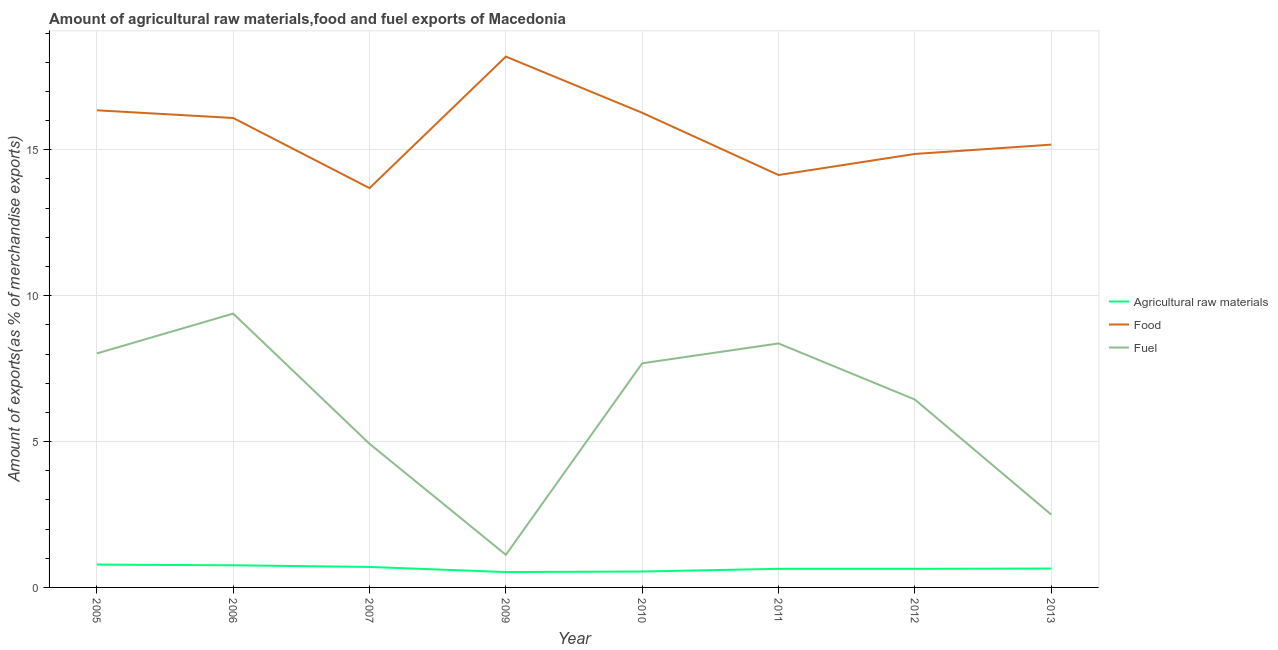Does the line corresponding to percentage of fuel exports intersect with the line corresponding to percentage of raw materials exports?
Keep it short and to the point. No. What is the percentage of food exports in 2013?
Give a very brief answer. 15.18. Across all years, what is the maximum percentage of food exports?
Your response must be concise. 18.19. Across all years, what is the minimum percentage of fuel exports?
Keep it short and to the point. 1.12. In which year was the percentage of food exports maximum?
Keep it short and to the point. 2009. What is the total percentage of fuel exports in the graph?
Offer a very short reply. 48.42. What is the difference between the percentage of raw materials exports in 2006 and that in 2007?
Give a very brief answer. 0.06. What is the difference between the percentage of raw materials exports in 2007 and the percentage of food exports in 2009?
Your response must be concise. -17.49. What is the average percentage of fuel exports per year?
Ensure brevity in your answer.  6.05. In the year 2012, what is the difference between the percentage of food exports and percentage of fuel exports?
Ensure brevity in your answer.  8.42. In how many years, is the percentage of raw materials exports greater than 15 %?
Keep it short and to the point. 0. What is the ratio of the percentage of food exports in 2009 to that in 2012?
Your answer should be compact. 1.22. What is the difference between the highest and the second highest percentage of food exports?
Your answer should be compact. 1.84. What is the difference between the highest and the lowest percentage of raw materials exports?
Your response must be concise. 0.25. Is the sum of the percentage of food exports in 2005 and 2011 greater than the maximum percentage of fuel exports across all years?
Your response must be concise. Yes. Is it the case that in every year, the sum of the percentage of raw materials exports and percentage of food exports is greater than the percentage of fuel exports?
Provide a short and direct response. Yes. How many lines are there?
Offer a very short reply. 3. How many years are there in the graph?
Provide a short and direct response. 8. Does the graph contain any zero values?
Ensure brevity in your answer.  No. Does the graph contain grids?
Give a very brief answer. Yes. How are the legend labels stacked?
Offer a terse response. Vertical. What is the title of the graph?
Provide a succinct answer. Amount of agricultural raw materials,food and fuel exports of Macedonia. What is the label or title of the Y-axis?
Your answer should be compact. Amount of exports(as % of merchandise exports). What is the Amount of exports(as % of merchandise exports) of Agricultural raw materials in 2005?
Keep it short and to the point. 0.78. What is the Amount of exports(as % of merchandise exports) in Food in 2005?
Provide a succinct answer. 16.35. What is the Amount of exports(as % of merchandise exports) of Fuel in 2005?
Provide a succinct answer. 8.02. What is the Amount of exports(as % of merchandise exports) in Agricultural raw materials in 2006?
Offer a terse response. 0.76. What is the Amount of exports(as % of merchandise exports) of Food in 2006?
Make the answer very short. 16.09. What is the Amount of exports(as % of merchandise exports) of Fuel in 2006?
Give a very brief answer. 9.38. What is the Amount of exports(as % of merchandise exports) of Agricultural raw materials in 2007?
Keep it short and to the point. 0.7. What is the Amount of exports(as % of merchandise exports) in Food in 2007?
Offer a terse response. 13.69. What is the Amount of exports(as % of merchandise exports) in Fuel in 2007?
Your response must be concise. 4.92. What is the Amount of exports(as % of merchandise exports) of Agricultural raw materials in 2009?
Offer a terse response. 0.53. What is the Amount of exports(as % of merchandise exports) of Food in 2009?
Ensure brevity in your answer.  18.19. What is the Amount of exports(as % of merchandise exports) in Fuel in 2009?
Your answer should be very brief. 1.12. What is the Amount of exports(as % of merchandise exports) of Agricultural raw materials in 2010?
Provide a succinct answer. 0.55. What is the Amount of exports(as % of merchandise exports) of Food in 2010?
Give a very brief answer. 16.27. What is the Amount of exports(as % of merchandise exports) in Fuel in 2010?
Offer a terse response. 7.68. What is the Amount of exports(as % of merchandise exports) in Agricultural raw materials in 2011?
Your response must be concise. 0.64. What is the Amount of exports(as % of merchandise exports) of Food in 2011?
Give a very brief answer. 14.13. What is the Amount of exports(as % of merchandise exports) in Fuel in 2011?
Keep it short and to the point. 8.36. What is the Amount of exports(as % of merchandise exports) in Agricultural raw materials in 2012?
Give a very brief answer. 0.64. What is the Amount of exports(as % of merchandise exports) of Food in 2012?
Offer a terse response. 14.86. What is the Amount of exports(as % of merchandise exports) of Fuel in 2012?
Your response must be concise. 6.44. What is the Amount of exports(as % of merchandise exports) in Agricultural raw materials in 2013?
Your answer should be compact. 0.65. What is the Amount of exports(as % of merchandise exports) of Food in 2013?
Give a very brief answer. 15.18. What is the Amount of exports(as % of merchandise exports) of Fuel in 2013?
Your answer should be very brief. 2.5. Across all years, what is the maximum Amount of exports(as % of merchandise exports) in Agricultural raw materials?
Keep it short and to the point. 0.78. Across all years, what is the maximum Amount of exports(as % of merchandise exports) of Food?
Your answer should be compact. 18.19. Across all years, what is the maximum Amount of exports(as % of merchandise exports) of Fuel?
Make the answer very short. 9.38. Across all years, what is the minimum Amount of exports(as % of merchandise exports) in Agricultural raw materials?
Your response must be concise. 0.53. Across all years, what is the minimum Amount of exports(as % of merchandise exports) of Food?
Give a very brief answer. 13.69. Across all years, what is the minimum Amount of exports(as % of merchandise exports) of Fuel?
Your answer should be very brief. 1.12. What is the total Amount of exports(as % of merchandise exports) in Agricultural raw materials in the graph?
Your response must be concise. 5.24. What is the total Amount of exports(as % of merchandise exports) of Food in the graph?
Give a very brief answer. 124.75. What is the total Amount of exports(as % of merchandise exports) in Fuel in the graph?
Provide a short and direct response. 48.42. What is the difference between the Amount of exports(as % of merchandise exports) of Agricultural raw materials in 2005 and that in 2006?
Your response must be concise. 0.02. What is the difference between the Amount of exports(as % of merchandise exports) of Food in 2005 and that in 2006?
Your answer should be very brief. 0.26. What is the difference between the Amount of exports(as % of merchandise exports) in Fuel in 2005 and that in 2006?
Offer a terse response. -1.37. What is the difference between the Amount of exports(as % of merchandise exports) of Agricultural raw materials in 2005 and that in 2007?
Offer a very short reply. 0.08. What is the difference between the Amount of exports(as % of merchandise exports) in Food in 2005 and that in 2007?
Your answer should be very brief. 2.67. What is the difference between the Amount of exports(as % of merchandise exports) of Fuel in 2005 and that in 2007?
Ensure brevity in your answer.  3.1. What is the difference between the Amount of exports(as % of merchandise exports) of Agricultural raw materials in 2005 and that in 2009?
Your answer should be very brief. 0.25. What is the difference between the Amount of exports(as % of merchandise exports) of Food in 2005 and that in 2009?
Make the answer very short. -1.84. What is the difference between the Amount of exports(as % of merchandise exports) in Fuel in 2005 and that in 2009?
Make the answer very short. 6.9. What is the difference between the Amount of exports(as % of merchandise exports) of Agricultural raw materials in 2005 and that in 2010?
Offer a very short reply. 0.24. What is the difference between the Amount of exports(as % of merchandise exports) in Food in 2005 and that in 2010?
Ensure brevity in your answer.  0.09. What is the difference between the Amount of exports(as % of merchandise exports) of Fuel in 2005 and that in 2010?
Give a very brief answer. 0.34. What is the difference between the Amount of exports(as % of merchandise exports) of Agricultural raw materials in 2005 and that in 2011?
Keep it short and to the point. 0.14. What is the difference between the Amount of exports(as % of merchandise exports) in Food in 2005 and that in 2011?
Your response must be concise. 2.22. What is the difference between the Amount of exports(as % of merchandise exports) in Fuel in 2005 and that in 2011?
Offer a very short reply. -0.34. What is the difference between the Amount of exports(as % of merchandise exports) of Agricultural raw materials in 2005 and that in 2012?
Give a very brief answer. 0.14. What is the difference between the Amount of exports(as % of merchandise exports) in Food in 2005 and that in 2012?
Offer a very short reply. 1.5. What is the difference between the Amount of exports(as % of merchandise exports) of Fuel in 2005 and that in 2012?
Give a very brief answer. 1.58. What is the difference between the Amount of exports(as % of merchandise exports) of Agricultural raw materials in 2005 and that in 2013?
Your answer should be very brief. 0.13. What is the difference between the Amount of exports(as % of merchandise exports) of Food in 2005 and that in 2013?
Give a very brief answer. 1.18. What is the difference between the Amount of exports(as % of merchandise exports) of Fuel in 2005 and that in 2013?
Your answer should be compact. 5.52. What is the difference between the Amount of exports(as % of merchandise exports) in Agricultural raw materials in 2006 and that in 2007?
Provide a succinct answer. 0.06. What is the difference between the Amount of exports(as % of merchandise exports) in Food in 2006 and that in 2007?
Ensure brevity in your answer.  2.4. What is the difference between the Amount of exports(as % of merchandise exports) of Fuel in 2006 and that in 2007?
Provide a succinct answer. 4.46. What is the difference between the Amount of exports(as % of merchandise exports) in Agricultural raw materials in 2006 and that in 2009?
Keep it short and to the point. 0.23. What is the difference between the Amount of exports(as % of merchandise exports) in Food in 2006 and that in 2009?
Your response must be concise. -2.1. What is the difference between the Amount of exports(as % of merchandise exports) in Fuel in 2006 and that in 2009?
Make the answer very short. 8.27. What is the difference between the Amount of exports(as % of merchandise exports) of Agricultural raw materials in 2006 and that in 2010?
Your answer should be very brief. 0.21. What is the difference between the Amount of exports(as % of merchandise exports) in Food in 2006 and that in 2010?
Your response must be concise. -0.18. What is the difference between the Amount of exports(as % of merchandise exports) of Fuel in 2006 and that in 2010?
Ensure brevity in your answer.  1.7. What is the difference between the Amount of exports(as % of merchandise exports) of Agricultural raw materials in 2006 and that in 2011?
Make the answer very short. 0.12. What is the difference between the Amount of exports(as % of merchandise exports) in Food in 2006 and that in 2011?
Your response must be concise. 1.96. What is the difference between the Amount of exports(as % of merchandise exports) in Fuel in 2006 and that in 2011?
Your answer should be compact. 1.02. What is the difference between the Amount of exports(as % of merchandise exports) of Agricultural raw materials in 2006 and that in 2012?
Offer a very short reply. 0.12. What is the difference between the Amount of exports(as % of merchandise exports) in Food in 2006 and that in 2012?
Offer a very short reply. 1.23. What is the difference between the Amount of exports(as % of merchandise exports) of Fuel in 2006 and that in 2012?
Offer a very short reply. 2.95. What is the difference between the Amount of exports(as % of merchandise exports) of Agricultural raw materials in 2006 and that in 2013?
Ensure brevity in your answer.  0.11. What is the difference between the Amount of exports(as % of merchandise exports) of Food in 2006 and that in 2013?
Ensure brevity in your answer.  0.91. What is the difference between the Amount of exports(as % of merchandise exports) of Fuel in 2006 and that in 2013?
Ensure brevity in your answer.  6.89. What is the difference between the Amount of exports(as % of merchandise exports) in Agricultural raw materials in 2007 and that in 2009?
Ensure brevity in your answer.  0.17. What is the difference between the Amount of exports(as % of merchandise exports) of Food in 2007 and that in 2009?
Keep it short and to the point. -4.51. What is the difference between the Amount of exports(as % of merchandise exports) in Fuel in 2007 and that in 2009?
Provide a succinct answer. 3.8. What is the difference between the Amount of exports(as % of merchandise exports) in Agricultural raw materials in 2007 and that in 2010?
Offer a terse response. 0.16. What is the difference between the Amount of exports(as % of merchandise exports) of Food in 2007 and that in 2010?
Your response must be concise. -2.58. What is the difference between the Amount of exports(as % of merchandise exports) of Fuel in 2007 and that in 2010?
Offer a very short reply. -2.76. What is the difference between the Amount of exports(as % of merchandise exports) in Agricultural raw materials in 2007 and that in 2011?
Make the answer very short. 0.06. What is the difference between the Amount of exports(as % of merchandise exports) in Food in 2007 and that in 2011?
Offer a very short reply. -0.45. What is the difference between the Amount of exports(as % of merchandise exports) of Fuel in 2007 and that in 2011?
Your answer should be compact. -3.44. What is the difference between the Amount of exports(as % of merchandise exports) in Agricultural raw materials in 2007 and that in 2012?
Ensure brevity in your answer.  0.06. What is the difference between the Amount of exports(as % of merchandise exports) in Food in 2007 and that in 2012?
Your answer should be very brief. -1.17. What is the difference between the Amount of exports(as % of merchandise exports) in Fuel in 2007 and that in 2012?
Make the answer very short. -1.52. What is the difference between the Amount of exports(as % of merchandise exports) in Agricultural raw materials in 2007 and that in 2013?
Ensure brevity in your answer.  0.05. What is the difference between the Amount of exports(as % of merchandise exports) in Food in 2007 and that in 2013?
Your answer should be compact. -1.49. What is the difference between the Amount of exports(as % of merchandise exports) in Fuel in 2007 and that in 2013?
Keep it short and to the point. 2.43. What is the difference between the Amount of exports(as % of merchandise exports) in Agricultural raw materials in 2009 and that in 2010?
Offer a terse response. -0.02. What is the difference between the Amount of exports(as % of merchandise exports) of Food in 2009 and that in 2010?
Provide a succinct answer. 1.93. What is the difference between the Amount of exports(as % of merchandise exports) in Fuel in 2009 and that in 2010?
Offer a terse response. -6.56. What is the difference between the Amount of exports(as % of merchandise exports) in Agricultural raw materials in 2009 and that in 2011?
Provide a succinct answer. -0.11. What is the difference between the Amount of exports(as % of merchandise exports) of Food in 2009 and that in 2011?
Offer a terse response. 4.06. What is the difference between the Amount of exports(as % of merchandise exports) in Fuel in 2009 and that in 2011?
Make the answer very short. -7.24. What is the difference between the Amount of exports(as % of merchandise exports) of Agricultural raw materials in 2009 and that in 2012?
Keep it short and to the point. -0.11. What is the difference between the Amount of exports(as % of merchandise exports) of Food in 2009 and that in 2012?
Make the answer very short. 3.34. What is the difference between the Amount of exports(as % of merchandise exports) in Fuel in 2009 and that in 2012?
Make the answer very short. -5.32. What is the difference between the Amount of exports(as % of merchandise exports) in Agricultural raw materials in 2009 and that in 2013?
Offer a terse response. -0.12. What is the difference between the Amount of exports(as % of merchandise exports) of Food in 2009 and that in 2013?
Your answer should be very brief. 3.02. What is the difference between the Amount of exports(as % of merchandise exports) in Fuel in 2009 and that in 2013?
Your answer should be very brief. -1.38. What is the difference between the Amount of exports(as % of merchandise exports) in Agricultural raw materials in 2010 and that in 2011?
Ensure brevity in your answer.  -0.09. What is the difference between the Amount of exports(as % of merchandise exports) in Food in 2010 and that in 2011?
Offer a terse response. 2.13. What is the difference between the Amount of exports(as % of merchandise exports) in Fuel in 2010 and that in 2011?
Your response must be concise. -0.68. What is the difference between the Amount of exports(as % of merchandise exports) of Agricultural raw materials in 2010 and that in 2012?
Your answer should be very brief. -0.09. What is the difference between the Amount of exports(as % of merchandise exports) in Food in 2010 and that in 2012?
Offer a very short reply. 1.41. What is the difference between the Amount of exports(as % of merchandise exports) of Fuel in 2010 and that in 2012?
Keep it short and to the point. 1.24. What is the difference between the Amount of exports(as % of merchandise exports) in Agricultural raw materials in 2010 and that in 2013?
Keep it short and to the point. -0.1. What is the difference between the Amount of exports(as % of merchandise exports) in Food in 2010 and that in 2013?
Your answer should be very brief. 1.09. What is the difference between the Amount of exports(as % of merchandise exports) in Fuel in 2010 and that in 2013?
Offer a very short reply. 5.19. What is the difference between the Amount of exports(as % of merchandise exports) in Food in 2011 and that in 2012?
Your answer should be compact. -0.72. What is the difference between the Amount of exports(as % of merchandise exports) in Fuel in 2011 and that in 2012?
Your response must be concise. 1.92. What is the difference between the Amount of exports(as % of merchandise exports) of Agricultural raw materials in 2011 and that in 2013?
Your answer should be very brief. -0.01. What is the difference between the Amount of exports(as % of merchandise exports) of Food in 2011 and that in 2013?
Ensure brevity in your answer.  -1.04. What is the difference between the Amount of exports(as % of merchandise exports) of Fuel in 2011 and that in 2013?
Give a very brief answer. 5.86. What is the difference between the Amount of exports(as % of merchandise exports) of Agricultural raw materials in 2012 and that in 2013?
Offer a terse response. -0.01. What is the difference between the Amount of exports(as % of merchandise exports) in Food in 2012 and that in 2013?
Offer a terse response. -0.32. What is the difference between the Amount of exports(as % of merchandise exports) in Fuel in 2012 and that in 2013?
Offer a very short reply. 3.94. What is the difference between the Amount of exports(as % of merchandise exports) of Agricultural raw materials in 2005 and the Amount of exports(as % of merchandise exports) of Food in 2006?
Ensure brevity in your answer.  -15.31. What is the difference between the Amount of exports(as % of merchandise exports) of Agricultural raw materials in 2005 and the Amount of exports(as % of merchandise exports) of Fuel in 2006?
Make the answer very short. -8.6. What is the difference between the Amount of exports(as % of merchandise exports) in Food in 2005 and the Amount of exports(as % of merchandise exports) in Fuel in 2006?
Your answer should be compact. 6.97. What is the difference between the Amount of exports(as % of merchandise exports) of Agricultural raw materials in 2005 and the Amount of exports(as % of merchandise exports) of Food in 2007?
Provide a short and direct response. -12.9. What is the difference between the Amount of exports(as % of merchandise exports) of Agricultural raw materials in 2005 and the Amount of exports(as % of merchandise exports) of Fuel in 2007?
Keep it short and to the point. -4.14. What is the difference between the Amount of exports(as % of merchandise exports) in Food in 2005 and the Amount of exports(as % of merchandise exports) in Fuel in 2007?
Your answer should be very brief. 11.43. What is the difference between the Amount of exports(as % of merchandise exports) in Agricultural raw materials in 2005 and the Amount of exports(as % of merchandise exports) in Food in 2009?
Keep it short and to the point. -17.41. What is the difference between the Amount of exports(as % of merchandise exports) of Agricultural raw materials in 2005 and the Amount of exports(as % of merchandise exports) of Fuel in 2009?
Your answer should be compact. -0.34. What is the difference between the Amount of exports(as % of merchandise exports) in Food in 2005 and the Amount of exports(as % of merchandise exports) in Fuel in 2009?
Ensure brevity in your answer.  15.23. What is the difference between the Amount of exports(as % of merchandise exports) of Agricultural raw materials in 2005 and the Amount of exports(as % of merchandise exports) of Food in 2010?
Provide a short and direct response. -15.48. What is the difference between the Amount of exports(as % of merchandise exports) in Agricultural raw materials in 2005 and the Amount of exports(as % of merchandise exports) in Fuel in 2010?
Your response must be concise. -6.9. What is the difference between the Amount of exports(as % of merchandise exports) in Food in 2005 and the Amount of exports(as % of merchandise exports) in Fuel in 2010?
Your response must be concise. 8.67. What is the difference between the Amount of exports(as % of merchandise exports) of Agricultural raw materials in 2005 and the Amount of exports(as % of merchandise exports) of Food in 2011?
Provide a succinct answer. -13.35. What is the difference between the Amount of exports(as % of merchandise exports) in Agricultural raw materials in 2005 and the Amount of exports(as % of merchandise exports) in Fuel in 2011?
Make the answer very short. -7.58. What is the difference between the Amount of exports(as % of merchandise exports) of Food in 2005 and the Amount of exports(as % of merchandise exports) of Fuel in 2011?
Offer a terse response. 7.99. What is the difference between the Amount of exports(as % of merchandise exports) in Agricultural raw materials in 2005 and the Amount of exports(as % of merchandise exports) in Food in 2012?
Provide a short and direct response. -14.07. What is the difference between the Amount of exports(as % of merchandise exports) in Agricultural raw materials in 2005 and the Amount of exports(as % of merchandise exports) in Fuel in 2012?
Offer a very short reply. -5.66. What is the difference between the Amount of exports(as % of merchandise exports) of Food in 2005 and the Amount of exports(as % of merchandise exports) of Fuel in 2012?
Give a very brief answer. 9.91. What is the difference between the Amount of exports(as % of merchandise exports) of Agricultural raw materials in 2005 and the Amount of exports(as % of merchandise exports) of Food in 2013?
Offer a very short reply. -14.39. What is the difference between the Amount of exports(as % of merchandise exports) of Agricultural raw materials in 2005 and the Amount of exports(as % of merchandise exports) of Fuel in 2013?
Your response must be concise. -1.72. What is the difference between the Amount of exports(as % of merchandise exports) in Food in 2005 and the Amount of exports(as % of merchandise exports) in Fuel in 2013?
Your answer should be compact. 13.86. What is the difference between the Amount of exports(as % of merchandise exports) in Agricultural raw materials in 2006 and the Amount of exports(as % of merchandise exports) in Food in 2007?
Offer a terse response. -12.93. What is the difference between the Amount of exports(as % of merchandise exports) in Agricultural raw materials in 2006 and the Amount of exports(as % of merchandise exports) in Fuel in 2007?
Offer a terse response. -4.16. What is the difference between the Amount of exports(as % of merchandise exports) of Food in 2006 and the Amount of exports(as % of merchandise exports) of Fuel in 2007?
Keep it short and to the point. 11.17. What is the difference between the Amount of exports(as % of merchandise exports) of Agricultural raw materials in 2006 and the Amount of exports(as % of merchandise exports) of Food in 2009?
Give a very brief answer. -17.43. What is the difference between the Amount of exports(as % of merchandise exports) of Agricultural raw materials in 2006 and the Amount of exports(as % of merchandise exports) of Fuel in 2009?
Offer a terse response. -0.36. What is the difference between the Amount of exports(as % of merchandise exports) of Food in 2006 and the Amount of exports(as % of merchandise exports) of Fuel in 2009?
Make the answer very short. 14.97. What is the difference between the Amount of exports(as % of merchandise exports) of Agricultural raw materials in 2006 and the Amount of exports(as % of merchandise exports) of Food in 2010?
Provide a short and direct response. -15.51. What is the difference between the Amount of exports(as % of merchandise exports) in Agricultural raw materials in 2006 and the Amount of exports(as % of merchandise exports) in Fuel in 2010?
Your answer should be very brief. -6.92. What is the difference between the Amount of exports(as % of merchandise exports) in Food in 2006 and the Amount of exports(as % of merchandise exports) in Fuel in 2010?
Your answer should be compact. 8.41. What is the difference between the Amount of exports(as % of merchandise exports) of Agricultural raw materials in 2006 and the Amount of exports(as % of merchandise exports) of Food in 2011?
Provide a short and direct response. -13.37. What is the difference between the Amount of exports(as % of merchandise exports) of Agricultural raw materials in 2006 and the Amount of exports(as % of merchandise exports) of Fuel in 2011?
Offer a terse response. -7.6. What is the difference between the Amount of exports(as % of merchandise exports) of Food in 2006 and the Amount of exports(as % of merchandise exports) of Fuel in 2011?
Provide a short and direct response. 7.73. What is the difference between the Amount of exports(as % of merchandise exports) in Agricultural raw materials in 2006 and the Amount of exports(as % of merchandise exports) in Food in 2012?
Your answer should be compact. -14.1. What is the difference between the Amount of exports(as % of merchandise exports) of Agricultural raw materials in 2006 and the Amount of exports(as % of merchandise exports) of Fuel in 2012?
Your answer should be very brief. -5.68. What is the difference between the Amount of exports(as % of merchandise exports) in Food in 2006 and the Amount of exports(as % of merchandise exports) in Fuel in 2012?
Make the answer very short. 9.65. What is the difference between the Amount of exports(as % of merchandise exports) in Agricultural raw materials in 2006 and the Amount of exports(as % of merchandise exports) in Food in 2013?
Your response must be concise. -14.42. What is the difference between the Amount of exports(as % of merchandise exports) in Agricultural raw materials in 2006 and the Amount of exports(as % of merchandise exports) in Fuel in 2013?
Your answer should be compact. -1.74. What is the difference between the Amount of exports(as % of merchandise exports) of Food in 2006 and the Amount of exports(as % of merchandise exports) of Fuel in 2013?
Provide a short and direct response. 13.59. What is the difference between the Amount of exports(as % of merchandise exports) of Agricultural raw materials in 2007 and the Amount of exports(as % of merchandise exports) of Food in 2009?
Ensure brevity in your answer.  -17.49. What is the difference between the Amount of exports(as % of merchandise exports) in Agricultural raw materials in 2007 and the Amount of exports(as % of merchandise exports) in Fuel in 2009?
Keep it short and to the point. -0.42. What is the difference between the Amount of exports(as % of merchandise exports) of Food in 2007 and the Amount of exports(as % of merchandise exports) of Fuel in 2009?
Provide a short and direct response. 12.57. What is the difference between the Amount of exports(as % of merchandise exports) of Agricultural raw materials in 2007 and the Amount of exports(as % of merchandise exports) of Food in 2010?
Your answer should be compact. -15.56. What is the difference between the Amount of exports(as % of merchandise exports) of Agricultural raw materials in 2007 and the Amount of exports(as % of merchandise exports) of Fuel in 2010?
Provide a short and direct response. -6.98. What is the difference between the Amount of exports(as % of merchandise exports) in Food in 2007 and the Amount of exports(as % of merchandise exports) in Fuel in 2010?
Keep it short and to the point. 6. What is the difference between the Amount of exports(as % of merchandise exports) of Agricultural raw materials in 2007 and the Amount of exports(as % of merchandise exports) of Food in 2011?
Provide a short and direct response. -13.43. What is the difference between the Amount of exports(as % of merchandise exports) in Agricultural raw materials in 2007 and the Amount of exports(as % of merchandise exports) in Fuel in 2011?
Keep it short and to the point. -7.66. What is the difference between the Amount of exports(as % of merchandise exports) of Food in 2007 and the Amount of exports(as % of merchandise exports) of Fuel in 2011?
Offer a very short reply. 5.32. What is the difference between the Amount of exports(as % of merchandise exports) in Agricultural raw materials in 2007 and the Amount of exports(as % of merchandise exports) in Food in 2012?
Provide a short and direct response. -14.15. What is the difference between the Amount of exports(as % of merchandise exports) in Agricultural raw materials in 2007 and the Amount of exports(as % of merchandise exports) in Fuel in 2012?
Ensure brevity in your answer.  -5.74. What is the difference between the Amount of exports(as % of merchandise exports) of Food in 2007 and the Amount of exports(as % of merchandise exports) of Fuel in 2012?
Offer a very short reply. 7.25. What is the difference between the Amount of exports(as % of merchandise exports) of Agricultural raw materials in 2007 and the Amount of exports(as % of merchandise exports) of Food in 2013?
Offer a terse response. -14.47. What is the difference between the Amount of exports(as % of merchandise exports) in Agricultural raw materials in 2007 and the Amount of exports(as % of merchandise exports) in Fuel in 2013?
Ensure brevity in your answer.  -1.8. What is the difference between the Amount of exports(as % of merchandise exports) of Food in 2007 and the Amount of exports(as % of merchandise exports) of Fuel in 2013?
Your response must be concise. 11.19. What is the difference between the Amount of exports(as % of merchandise exports) in Agricultural raw materials in 2009 and the Amount of exports(as % of merchandise exports) in Food in 2010?
Your response must be concise. -15.74. What is the difference between the Amount of exports(as % of merchandise exports) in Agricultural raw materials in 2009 and the Amount of exports(as % of merchandise exports) in Fuel in 2010?
Offer a very short reply. -7.15. What is the difference between the Amount of exports(as % of merchandise exports) of Food in 2009 and the Amount of exports(as % of merchandise exports) of Fuel in 2010?
Your response must be concise. 10.51. What is the difference between the Amount of exports(as % of merchandise exports) in Agricultural raw materials in 2009 and the Amount of exports(as % of merchandise exports) in Food in 2011?
Keep it short and to the point. -13.61. What is the difference between the Amount of exports(as % of merchandise exports) of Agricultural raw materials in 2009 and the Amount of exports(as % of merchandise exports) of Fuel in 2011?
Your response must be concise. -7.83. What is the difference between the Amount of exports(as % of merchandise exports) of Food in 2009 and the Amount of exports(as % of merchandise exports) of Fuel in 2011?
Your response must be concise. 9.83. What is the difference between the Amount of exports(as % of merchandise exports) of Agricultural raw materials in 2009 and the Amount of exports(as % of merchandise exports) of Food in 2012?
Your answer should be compact. -14.33. What is the difference between the Amount of exports(as % of merchandise exports) of Agricultural raw materials in 2009 and the Amount of exports(as % of merchandise exports) of Fuel in 2012?
Make the answer very short. -5.91. What is the difference between the Amount of exports(as % of merchandise exports) in Food in 2009 and the Amount of exports(as % of merchandise exports) in Fuel in 2012?
Your answer should be very brief. 11.75. What is the difference between the Amount of exports(as % of merchandise exports) in Agricultural raw materials in 2009 and the Amount of exports(as % of merchandise exports) in Food in 2013?
Make the answer very short. -14.65. What is the difference between the Amount of exports(as % of merchandise exports) in Agricultural raw materials in 2009 and the Amount of exports(as % of merchandise exports) in Fuel in 2013?
Your answer should be very brief. -1.97. What is the difference between the Amount of exports(as % of merchandise exports) of Food in 2009 and the Amount of exports(as % of merchandise exports) of Fuel in 2013?
Your answer should be very brief. 15.7. What is the difference between the Amount of exports(as % of merchandise exports) of Agricultural raw materials in 2010 and the Amount of exports(as % of merchandise exports) of Food in 2011?
Provide a succinct answer. -13.59. What is the difference between the Amount of exports(as % of merchandise exports) of Agricultural raw materials in 2010 and the Amount of exports(as % of merchandise exports) of Fuel in 2011?
Your response must be concise. -7.82. What is the difference between the Amount of exports(as % of merchandise exports) of Food in 2010 and the Amount of exports(as % of merchandise exports) of Fuel in 2011?
Your response must be concise. 7.9. What is the difference between the Amount of exports(as % of merchandise exports) of Agricultural raw materials in 2010 and the Amount of exports(as % of merchandise exports) of Food in 2012?
Make the answer very short. -14.31. What is the difference between the Amount of exports(as % of merchandise exports) in Agricultural raw materials in 2010 and the Amount of exports(as % of merchandise exports) in Fuel in 2012?
Your response must be concise. -5.89. What is the difference between the Amount of exports(as % of merchandise exports) in Food in 2010 and the Amount of exports(as % of merchandise exports) in Fuel in 2012?
Offer a terse response. 9.83. What is the difference between the Amount of exports(as % of merchandise exports) of Agricultural raw materials in 2010 and the Amount of exports(as % of merchandise exports) of Food in 2013?
Offer a terse response. -14.63. What is the difference between the Amount of exports(as % of merchandise exports) of Agricultural raw materials in 2010 and the Amount of exports(as % of merchandise exports) of Fuel in 2013?
Keep it short and to the point. -1.95. What is the difference between the Amount of exports(as % of merchandise exports) of Food in 2010 and the Amount of exports(as % of merchandise exports) of Fuel in 2013?
Provide a short and direct response. 13.77. What is the difference between the Amount of exports(as % of merchandise exports) of Agricultural raw materials in 2011 and the Amount of exports(as % of merchandise exports) of Food in 2012?
Your response must be concise. -14.22. What is the difference between the Amount of exports(as % of merchandise exports) in Agricultural raw materials in 2011 and the Amount of exports(as % of merchandise exports) in Fuel in 2012?
Offer a very short reply. -5.8. What is the difference between the Amount of exports(as % of merchandise exports) of Food in 2011 and the Amount of exports(as % of merchandise exports) of Fuel in 2012?
Give a very brief answer. 7.7. What is the difference between the Amount of exports(as % of merchandise exports) of Agricultural raw materials in 2011 and the Amount of exports(as % of merchandise exports) of Food in 2013?
Provide a short and direct response. -14.54. What is the difference between the Amount of exports(as % of merchandise exports) of Agricultural raw materials in 2011 and the Amount of exports(as % of merchandise exports) of Fuel in 2013?
Your answer should be compact. -1.86. What is the difference between the Amount of exports(as % of merchandise exports) of Food in 2011 and the Amount of exports(as % of merchandise exports) of Fuel in 2013?
Provide a short and direct response. 11.64. What is the difference between the Amount of exports(as % of merchandise exports) in Agricultural raw materials in 2012 and the Amount of exports(as % of merchandise exports) in Food in 2013?
Keep it short and to the point. -14.54. What is the difference between the Amount of exports(as % of merchandise exports) of Agricultural raw materials in 2012 and the Amount of exports(as % of merchandise exports) of Fuel in 2013?
Ensure brevity in your answer.  -1.86. What is the difference between the Amount of exports(as % of merchandise exports) of Food in 2012 and the Amount of exports(as % of merchandise exports) of Fuel in 2013?
Make the answer very short. 12.36. What is the average Amount of exports(as % of merchandise exports) of Agricultural raw materials per year?
Your answer should be compact. 0.65. What is the average Amount of exports(as % of merchandise exports) in Food per year?
Give a very brief answer. 15.59. What is the average Amount of exports(as % of merchandise exports) in Fuel per year?
Provide a succinct answer. 6.05. In the year 2005, what is the difference between the Amount of exports(as % of merchandise exports) in Agricultural raw materials and Amount of exports(as % of merchandise exports) in Food?
Your response must be concise. -15.57. In the year 2005, what is the difference between the Amount of exports(as % of merchandise exports) of Agricultural raw materials and Amount of exports(as % of merchandise exports) of Fuel?
Provide a succinct answer. -7.24. In the year 2005, what is the difference between the Amount of exports(as % of merchandise exports) in Food and Amount of exports(as % of merchandise exports) in Fuel?
Make the answer very short. 8.33. In the year 2006, what is the difference between the Amount of exports(as % of merchandise exports) of Agricultural raw materials and Amount of exports(as % of merchandise exports) of Food?
Give a very brief answer. -15.33. In the year 2006, what is the difference between the Amount of exports(as % of merchandise exports) in Agricultural raw materials and Amount of exports(as % of merchandise exports) in Fuel?
Your response must be concise. -8.63. In the year 2006, what is the difference between the Amount of exports(as % of merchandise exports) of Food and Amount of exports(as % of merchandise exports) of Fuel?
Offer a terse response. 6.7. In the year 2007, what is the difference between the Amount of exports(as % of merchandise exports) of Agricultural raw materials and Amount of exports(as % of merchandise exports) of Food?
Offer a very short reply. -12.98. In the year 2007, what is the difference between the Amount of exports(as % of merchandise exports) in Agricultural raw materials and Amount of exports(as % of merchandise exports) in Fuel?
Provide a succinct answer. -4.22. In the year 2007, what is the difference between the Amount of exports(as % of merchandise exports) of Food and Amount of exports(as % of merchandise exports) of Fuel?
Make the answer very short. 8.76. In the year 2009, what is the difference between the Amount of exports(as % of merchandise exports) in Agricultural raw materials and Amount of exports(as % of merchandise exports) in Food?
Offer a very short reply. -17.67. In the year 2009, what is the difference between the Amount of exports(as % of merchandise exports) of Agricultural raw materials and Amount of exports(as % of merchandise exports) of Fuel?
Provide a succinct answer. -0.59. In the year 2009, what is the difference between the Amount of exports(as % of merchandise exports) in Food and Amount of exports(as % of merchandise exports) in Fuel?
Keep it short and to the point. 17.07. In the year 2010, what is the difference between the Amount of exports(as % of merchandise exports) of Agricultural raw materials and Amount of exports(as % of merchandise exports) of Food?
Your answer should be compact. -15.72. In the year 2010, what is the difference between the Amount of exports(as % of merchandise exports) of Agricultural raw materials and Amount of exports(as % of merchandise exports) of Fuel?
Your response must be concise. -7.14. In the year 2010, what is the difference between the Amount of exports(as % of merchandise exports) in Food and Amount of exports(as % of merchandise exports) in Fuel?
Ensure brevity in your answer.  8.58. In the year 2011, what is the difference between the Amount of exports(as % of merchandise exports) of Agricultural raw materials and Amount of exports(as % of merchandise exports) of Food?
Make the answer very short. -13.5. In the year 2011, what is the difference between the Amount of exports(as % of merchandise exports) in Agricultural raw materials and Amount of exports(as % of merchandise exports) in Fuel?
Provide a short and direct response. -7.72. In the year 2011, what is the difference between the Amount of exports(as % of merchandise exports) of Food and Amount of exports(as % of merchandise exports) of Fuel?
Provide a succinct answer. 5.77. In the year 2012, what is the difference between the Amount of exports(as % of merchandise exports) in Agricultural raw materials and Amount of exports(as % of merchandise exports) in Food?
Offer a terse response. -14.22. In the year 2012, what is the difference between the Amount of exports(as % of merchandise exports) in Agricultural raw materials and Amount of exports(as % of merchandise exports) in Fuel?
Offer a terse response. -5.8. In the year 2012, what is the difference between the Amount of exports(as % of merchandise exports) in Food and Amount of exports(as % of merchandise exports) in Fuel?
Offer a terse response. 8.42. In the year 2013, what is the difference between the Amount of exports(as % of merchandise exports) in Agricultural raw materials and Amount of exports(as % of merchandise exports) in Food?
Provide a succinct answer. -14.53. In the year 2013, what is the difference between the Amount of exports(as % of merchandise exports) of Agricultural raw materials and Amount of exports(as % of merchandise exports) of Fuel?
Your answer should be compact. -1.85. In the year 2013, what is the difference between the Amount of exports(as % of merchandise exports) of Food and Amount of exports(as % of merchandise exports) of Fuel?
Ensure brevity in your answer.  12.68. What is the ratio of the Amount of exports(as % of merchandise exports) of Agricultural raw materials in 2005 to that in 2006?
Keep it short and to the point. 1.03. What is the ratio of the Amount of exports(as % of merchandise exports) of Food in 2005 to that in 2006?
Make the answer very short. 1.02. What is the ratio of the Amount of exports(as % of merchandise exports) of Fuel in 2005 to that in 2006?
Your response must be concise. 0.85. What is the ratio of the Amount of exports(as % of merchandise exports) of Agricultural raw materials in 2005 to that in 2007?
Offer a terse response. 1.11. What is the ratio of the Amount of exports(as % of merchandise exports) of Food in 2005 to that in 2007?
Give a very brief answer. 1.19. What is the ratio of the Amount of exports(as % of merchandise exports) in Fuel in 2005 to that in 2007?
Provide a short and direct response. 1.63. What is the ratio of the Amount of exports(as % of merchandise exports) in Agricultural raw materials in 2005 to that in 2009?
Offer a terse response. 1.48. What is the ratio of the Amount of exports(as % of merchandise exports) of Food in 2005 to that in 2009?
Your answer should be compact. 0.9. What is the ratio of the Amount of exports(as % of merchandise exports) in Fuel in 2005 to that in 2009?
Provide a short and direct response. 7.17. What is the ratio of the Amount of exports(as % of merchandise exports) in Agricultural raw materials in 2005 to that in 2010?
Keep it short and to the point. 1.43. What is the ratio of the Amount of exports(as % of merchandise exports) of Food in 2005 to that in 2010?
Give a very brief answer. 1.01. What is the ratio of the Amount of exports(as % of merchandise exports) in Fuel in 2005 to that in 2010?
Provide a short and direct response. 1.04. What is the ratio of the Amount of exports(as % of merchandise exports) in Agricultural raw materials in 2005 to that in 2011?
Your answer should be compact. 1.23. What is the ratio of the Amount of exports(as % of merchandise exports) in Food in 2005 to that in 2011?
Your response must be concise. 1.16. What is the ratio of the Amount of exports(as % of merchandise exports) of Fuel in 2005 to that in 2011?
Provide a succinct answer. 0.96. What is the ratio of the Amount of exports(as % of merchandise exports) of Agricultural raw materials in 2005 to that in 2012?
Ensure brevity in your answer.  1.23. What is the ratio of the Amount of exports(as % of merchandise exports) of Food in 2005 to that in 2012?
Ensure brevity in your answer.  1.1. What is the ratio of the Amount of exports(as % of merchandise exports) of Fuel in 2005 to that in 2012?
Provide a short and direct response. 1.25. What is the ratio of the Amount of exports(as % of merchandise exports) in Agricultural raw materials in 2005 to that in 2013?
Provide a succinct answer. 1.21. What is the ratio of the Amount of exports(as % of merchandise exports) in Food in 2005 to that in 2013?
Offer a terse response. 1.08. What is the ratio of the Amount of exports(as % of merchandise exports) in Fuel in 2005 to that in 2013?
Provide a short and direct response. 3.21. What is the ratio of the Amount of exports(as % of merchandise exports) of Agricultural raw materials in 2006 to that in 2007?
Your response must be concise. 1.08. What is the ratio of the Amount of exports(as % of merchandise exports) in Food in 2006 to that in 2007?
Give a very brief answer. 1.18. What is the ratio of the Amount of exports(as % of merchandise exports) of Fuel in 2006 to that in 2007?
Offer a terse response. 1.91. What is the ratio of the Amount of exports(as % of merchandise exports) in Agricultural raw materials in 2006 to that in 2009?
Offer a very short reply. 1.44. What is the ratio of the Amount of exports(as % of merchandise exports) of Food in 2006 to that in 2009?
Offer a terse response. 0.88. What is the ratio of the Amount of exports(as % of merchandise exports) of Fuel in 2006 to that in 2009?
Your answer should be very brief. 8.4. What is the ratio of the Amount of exports(as % of merchandise exports) of Agricultural raw materials in 2006 to that in 2010?
Provide a short and direct response. 1.39. What is the ratio of the Amount of exports(as % of merchandise exports) of Fuel in 2006 to that in 2010?
Provide a short and direct response. 1.22. What is the ratio of the Amount of exports(as % of merchandise exports) in Agricultural raw materials in 2006 to that in 2011?
Offer a terse response. 1.19. What is the ratio of the Amount of exports(as % of merchandise exports) of Food in 2006 to that in 2011?
Keep it short and to the point. 1.14. What is the ratio of the Amount of exports(as % of merchandise exports) in Fuel in 2006 to that in 2011?
Provide a succinct answer. 1.12. What is the ratio of the Amount of exports(as % of merchandise exports) in Agricultural raw materials in 2006 to that in 2012?
Offer a terse response. 1.19. What is the ratio of the Amount of exports(as % of merchandise exports) in Food in 2006 to that in 2012?
Make the answer very short. 1.08. What is the ratio of the Amount of exports(as % of merchandise exports) of Fuel in 2006 to that in 2012?
Your answer should be very brief. 1.46. What is the ratio of the Amount of exports(as % of merchandise exports) in Agricultural raw materials in 2006 to that in 2013?
Offer a terse response. 1.17. What is the ratio of the Amount of exports(as % of merchandise exports) in Food in 2006 to that in 2013?
Provide a succinct answer. 1.06. What is the ratio of the Amount of exports(as % of merchandise exports) in Fuel in 2006 to that in 2013?
Make the answer very short. 3.76. What is the ratio of the Amount of exports(as % of merchandise exports) of Agricultural raw materials in 2007 to that in 2009?
Ensure brevity in your answer.  1.33. What is the ratio of the Amount of exports(as % of merchandise exports) in Food in 2007 to that in 2009?
Your answer should be compact. 0.75. What is the ratio of the Amount of exports(as % of merchandise exports) of Fuel in 2007 to that in 2009?
Your answer should be very brief. 4.4. What is the ratio of the Amount of exports(as % of merchandise exports) of Agricultural raw materials in 2007 to that in 2010?
Keep it short and to the point. 1.29. What is the ratio of the Amount of exports(as % of merchandise exports) of Food in 2007 to that in 2010?
Make the answer very short. 0.84. What is the ratio of the Amount of exports(as % of merchandise exports) in Fuel in 2007 to that in 2010?
Your answer should be compact. 0.64. What is the ratio of the Amount of exports(as % of merchandise exports) of Agricultural raw materials in 2007 to that in 2011?
Make the answer very short. 1.1. What is the ratio of the Amount of exports(as % of merchandise exports) in Food in 2007 to that in 2011?
Provide a short and direct response. 0.97. What is the ratio of the Amount of exports(as % of merchandise exports) in Fuel in 2007 to that in 2011?
Make the answer very short. 0.59. What is the ratio of the Amount of exports(as % of merchandise exports) of Agricultural raw materials in 2007 to that in 2012?
Your answer should be compact. 1.1. What is the ratio of the Amount of exports(as % of merchandise exports) of Food in 2007 to that in 2012?
Ensure brevity in your answer.  0.92. What is the ratio of the Amount of exports(as % of merchandise exports) of Fuel in 2007 to that in 2012?
Your answer should be very brief. 0.76. What is the ratio of the Amount of exports(as % of merchandise exports) of Agricultural raw materials in 2007 to that in 2013?
Keep it short and to the point. 1.08. What is the ratio of the Amount of exports(as % of merchandise exports) of Food in 2007 to that in 2013?
Give a very brief answer. 0.9. What is the ratio of the Amount of exports(as % of merchandise exports) in Fuel in 2007 to that in 2013?
Keep it short and to the point. 1.97. What is the ratio of the Amount of exports(as % of merchandise exports) of Agricultural raw materials in 2009 to that in 2010?
Give a very brief answer. 0.97. What is the ratio of the Amount of exports(as % of merchandise exports) in Food in 2009 to that in 2010?
Your answer should be compact. 1.12. What is the ratio of the Amount of exports(as % of merchandise exports) of Fuel in 2009 to that in 2010?
Your answer should be very brief. 0.15. What is the ratio of the Amount of exports(as % of merchandise exports) of Agricultural raw materials in 2009 to that in 2011?
Your answer should be very brief. 0.83. What is the ratio of the Amount of exports(as % of merchandise exports) in Food in 2009 to that in 2011?
Give a very brief answer. 1.29. What is the ratio of the Amount of exports(as % of merchandise exports) of Fuel in 2009 to that in 2011?
Offer a terse response. 0.13. What is the ratio of the Amount of exports(as % of merchandise exports) of Agricultural raw materials in 2009 to that in 2012?
Your answer should be very brief. 0.83. What is the ratio of the Amount of exports(as % of merchandise exports) in Food in 2009 to that in 2012?
Your answer should be very brief. 1.22. What is the ratio of the Amount of exports(as % of merchandise exports) in Fuel in 2009 to that in 2012?
Your answer should be very brief. 0.17. What is the ratio of the Amount of exports(as % of merchandise exports) of Agricultural raw materials in 2009 to that in 2013?
Offer a very short reply. 0.81. What is the ratio of the Amount of exports(as % of merchandise exports) of Food in 2009 to that in 2013?
Make the answer very short. 1.2. What is the ratio of the Amount of exports(as % of merchandise exports) in Fuel in 2009 to that in 2013?
Make the answer very short. 0.45. What is the ratio of the Amount of exports(as % of merchandise exports) in Agricultural raw materials in 2010 to that in 2011?
Make the answer very short. 0.86. What is the ratio of the Amount of exports(as % of merchandise exports) in Food in 2010 to that in 2011?
Offer a very short reply. 1.15. What is the ratio of the Amount of exports(as % of merchandise exports) in Fuel in 2010 to that in 2011?
Offer a terse response. 0.92. What is the ratio of the Amount of exports(as % of merchandise exports) in Agricultural raw materials in 2010 to that in 2012?
Offer a very short reply. 0.86. What is the ratio of the Amount of exports(as % of merchandise exports) of Food in 2010 to that in 2012?
Offer a terse response. 1.09. What is the ratio of the Amount of exports(as % of merchandise exports) in Fuel in 2010 to that in 2012?
Offer a very short reply. 1.19. What is the ratio of the Amount of exports(as % of merchandise exports) of Agricultural raw materials in 2010 to that in 2013?
Your answer should be compact. 0.84. What is the ratio of the Amount of exports(as % of merchandise exports) in Food in 2010 to that in 2013?
Your answer should be compact. 1.07. What is the ratio of the Amount of exports(as % of merchandise exports) in Fuel in 2010 to that in 2013?
Your answer should be compact. 3.08. What is the ratio of the Amount of exports(as % of merchandise exports) in Agricultural raw materials in 2011 to that in 2012?
Offer a terse response. 1. What is the ratio of the Amount of exports(as % of merchandise exports) of Food in 2011 to that in 2012?
Ensure brevity in your answer.  0.95. What is the ratio of the Amount of exports(as % of merchandise exports) in Fuel in 2011 to that in 2012?
Your response must be concise. 1.3. What is the ratio of the Amount of exports(as % of merchandise exports) in Agricultural raw materials in 2011 to that in 2013?
Your answer should be very brief. 0.98. What is the ratio of the Amount of exports(as % of merchandise exports) in Food in 2011 to that in 2013?
Make the answer very short. 0.93. What is the ratio of the Amount of exports(as % of merchandise exports) of Fuel in 2011 to that in 2013?
Your answer should be very brief. 3.35. What is the ratio of the Amount of exports(as % of merchandise exports) of Agricultural raw materials in 2012 to that in 2013?
Give a very brief answer. 0.98. What is the ratio of the Amount of exports(as % of merchandise exports) in Food in 2012 to that in 2013?
Offer a terse response. 0.98. What is the ratio of the Amount of exports(as % of merchandise exports) in Fuel in 2012 to that in 2013?
Ensure brevity in your answer.  2.58. What is the difference between the highest and the second highest Amount of exports(as % of merchandise exports) of Agricultural raw materials?
Ensure brevity in your answer.  0.02. What is the difference between the highest and the second highest Amount of exports(as % of merchandise exports) of Food?
Offer a very short reply. 1.84. What is the difference between the highest and the second highest Amount of exports(as % of merchandise exports) of Fuel?
Your response must be concise. 1.02. What is the difference between the highest and the lowest Amount of exports(as % of merchandise exports) of Agricultural raw materials?
Provide a succinct answer. 0.25. What is the difference between the highest and the lowest Amount of exports(as % of merchandise exports) in Food?
Provide a succinct answer. 4.51. What is the difference between the highest and the lowest Amount of exports(as % of merchandise exports) of Fuel?
Ensure brevity in your answer.  8.27. 